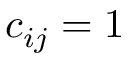Convert formula to latex. <formula><loc_0><loc_0><loc_500><loc_500>c _ { i j } = 1</formula> 